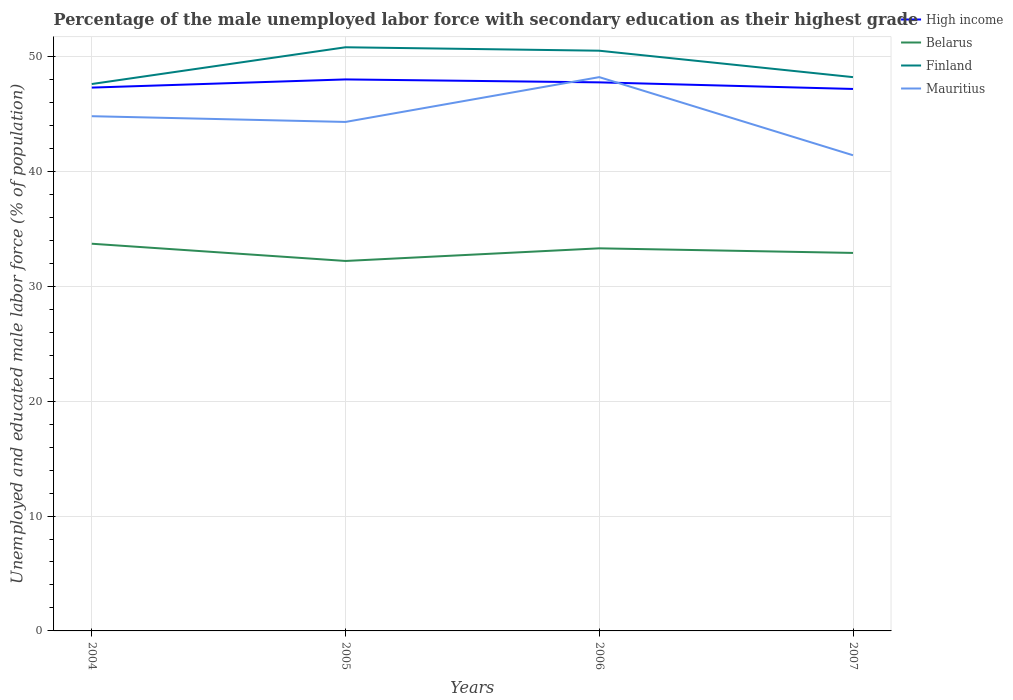Does the line corresponding to Finland intersect with the line corresponding to Belarus?
Your answer should be very brief. No. Across all years, what is the maximum percentage of the unemployed male labor force with secondary education in Finland?
Offer a very short reply. 47.6. In which year was the percentage of the unemployed male labor force with secondary education in Finland maximum?
Offer a terse response. 2004. What is the total percentage of the unemployed male labor force with secondary education in Belarus in the graph?
Your response must be concise. -1.1. What is the difference between the highest and the second highest percentage of the unemployed male labor force with secondary education in High income?
Your answer should be very brief. 0.83. What is the difference between the highest and the lowest percentage of the unemployed male labor force with secondary education in Mauritius?
Offer a very short reply. 2. How many years are there in the graph?
Make the answer very short. 4. What is the difference between two consecutive major ticks on the Y-axis?
Offer a very short reply. 10. Does the graph contain grids?
Offer a very short reply. Yes. How are the legend labels stacked?
Offer a very short reply. Vertical. What is the title of the graph?
Provide a succinct answer. Percentage of the male unemployed labor force with secondary education as their highest grade. What is the label or title of the Y-axis?
Your answer should be very brief. Unemployed and educated male labor force (% of population). What is the Unemployed and educated male labor force (% of population) of High income in 2004?
Offer a terse response. 47.29. What is the Unemployed and educated male labor force (% of population) in Belarus in 2004?
Provide a succinct answer. 33.7. What is the Unemployed and educated male labor force (% of population) of Finland in 2004?
Give a very brief answer. 47.6. What is the Unemployed and educated male labor force (% of population) of Mauritius in 2004?
Your answer should be very brief. 44.8. What is the Unemployed and educated male labor force (% of population) in High income in 2005?
Your response must be concise. 48. What is the Unemployed and educated male labor force (% of population) in Belarus in 2005?
Provide a succinct answer. 32.2. What is the Unemployed and educated male labor force (% of population) of Finland in 2005?
Keep it short and to the point. 50.8. What is the Unemployed and educated male labor force (% of population) in Mauritius in 2005?
Keep it short and to the point. 44.3. What is the Unemployed and educated male labor force (% of population) of High income in 2006?
Keep it short and to the point. 47.74. What is the Unemployed and educated male labor force (% of population) in Belarus in 2006?
Your answer should be very brief. 33.3. What is the Unemployed and educated male labor force (% of population) in Finland in 2006?
Your response must be concise. 50.5. What is the Unemployed and educated male labor force (% of population) in Mauritius in 2006?
Offer a very short reply. 48.2. What is the Unemployed and educated male labor force (% of population) in High income in 2007?
Offer a terse response. 47.17. What is the Unemployed and educated male labor force (% of population) in Belarus in 2007?
Your answer should be compact. 32.9. What is the Unemployed and educated male labor force (% of population) of Finland in 2007?
Offer a terse response. 48.2. What is the Unemployed and educated male labor force (% of population) in Mauritius in 2007?
Provide a short and direct response. 41.4. Across all years, what is the maximum Unemployed and educated male labor force (% of population) of High income?
Your answer should be compact. 48. Across all years, what is the maximum Unemployed and educated male labor force (% of population) of Belarus?
Give a very brief answer. 33.7. Across all years, what is the maximum Unemployed and educated male labor force (% of population) in Finland?
Make the answer very short. 50.8. Across all years, what is the maximum Unemployed and educated male labor force (% of population) of Mauritius?
Your answer should be compact. 48.2. Across all years, what is the minimum Unemployed and educated male labor force (% of population) of High income?
Provide a succinct answer. 47.17. Across all years, what is the minimum Unemployed and educated male labor force (% of population) of Belarus?
Offer a terse response. 32.2. Across all years, what is the minimum Unemployed and educated male labor force (% of population) of Finland?
Ensure brevity in your answer.  47.6. Across all years, what is the minimum Unemployed and educated male labor force (% of population) in Mauritius?
Provide a succinct answer. 41.4. What is the total Unemployed and educated male labor force (% of population) in High income in the graph?
Your answer should be very brief. 190.21. What is the total Unemployed and educated male labor force (% of population) in Belarus in the graph?
Provide a succinct answer. 132.1. What is the total Unemployed and educated male labor force (% of population) of Finland in the graph?
Offer a terse response. 197.1. What is the total Unemployed and educated male labor force (% of population) in Mauritius in the graph?
Ensure brevity in your answer.  178.7. What is the difference between the Unemployed and educated male labor force (% of population) in High income in 2004 and that in 2005?
Your answer should be very brief. -0.71. What is the difference between the Unemployed and educated male labor force (% of population) of Finland in 2004 and that in 2005?
Provide a succinct answer. -3.2. What is the difference between the Unemployed and educated male labor force (% of population) of High income in 2004 and that in 2006?
Provide a succinct answer. -0.46. What is the difference between the Unemployed and educated male labor force (% of population) of High income in 2004 and that in 2007?
Your response must be concise. 0.12. What is the difference between the Unemployed and educated male labor force (% of population) of Finland in 2004 and that in 2007?
Give a very brief answer. -0.6. What is the difference between the Unemployed and educated male labor force (% of population) of Mauritius in 2004 and that in 2007?
Your response must be concise. 3.4. What is the difference between the Unemployed and educated male labor force (% of population) of High income in 2005 and that in 2006?
Provide a succinct answer. 0.26. What is the difference between the Unemployed and educated male labor force (% of population) in Finland in 2005 and that in 2006?
Your answer should be very brief. 0.3. What is the difference between the Unemployed and educated male labor force (% of population) in Mauritius in 2005 and that in 2006?
Your response must be concise. -3.9. What is the difference between the Unemployed and educated male labor force (% of population) of High income in 2005 and that in 2007?
Provide a short and direct response. 0.83. What is the difference between the Unemployed and educated male labor force (% of population) of Belarus in 2005 and that in 2007?
Keep it short and to the point. -0.7. What is the difference between the Unemployed and educated male labor force (% of population) of Finland in 2005 and that in 2007?
Make the answer very short. 2.6. What is the difference between the Unemployed and educated male labor force (% of population) of High income in 2006 and that in 2007?
Keep it short and to the point. 0.57. What is the difference between the Unemployed and educated male labor force (% of population) of High income in 2004 and the Unemployed and educated male labor force (% of population) of Belarus in 2005?
Provide a short and direct response. 15.09. What is the difference between the Unemployed and educated male labor force (% of population) in High income in 2004 and the Unemployed and educated male labor force (% of population) in Finland in 2005?
Your answer should be very brief. -3.51. What is the difference between the Unemployed and educated male labor force (% of population) of High income in 2004 and the Unemployed and educated male labor force (% of population) of Mauritius in 2005?
Your response must be concise. 2.99. What is the difference between the Unemployed and educated male labor force (% of population) of Belarus in 2004 and the Unemployed and educated male labor force (% of population) of Finland in 2005?
Your response must be concise. -17.1. What is the difference between the Unemployed and educated male labor force (% of population) in Belarus in 2004 and the Unemployed and educated male labor force (% of population) in Mauritius in 2005?
Your answer should be very brief. -10.6. What is the difference between the Unemployed and educated male labor force (% of population) in Finland in 2004 and the Unemployed and educated male labor force (% of population) in Mauritius in 2005?
Your answer should be very brief. 3.3. What is the difference between the Unemployed and educated male labor force (% of population) in High income in 2004 and the Unemployed and educated male labor force (% of population) in Belarus in 2006?
Offer a very short reply. 13.99. What is the difference between the Unemployed and educated male labor force (% of population) of High income in 2004 and the Unemployed and educated male labor force (% of population) of Finland in 2006?
Your response must be concise. -3.21. What is the difference between the Unemployed and educated male labor force (% of population) of High income in 2004 and the Unemployed and educated male labor force (% of population) of Mauritius in 2006?
Give a very brief answer. -0.91. What is the difference between the Unemployed and educated male labor force (% of population) in Belarus in 2004 and the Unemployed and educated male labor force (% of population) in Finland in 2006?
Offer a very short reply. -16.8. What is the difference between the Unemployed and educated male labor force (% of population) in Finland in 2004 and the Unemployed and educated male labor force (% of population) in Mauritius in 2006?
Ensure brevity in your answer.  -0.6. What is the difference between the Unemployed and educated male labor force (% of population) of High income in 2004 and the Unemployed and educated male labor force (% of population) of Belarus in 2007?
Your answer should be very brief. 14.39. What is the difference between the Unemployed and educated male labor force (% of population) in High income in 2004 and the Unemployed and educated male labor force (% of population) in Finland in 2007?
Offer a very short reply. -0.91. What is the difference between the Unemployed and educated male labor force (% of population) of High income in 2004 and the Unemployed and educated male labor force (% of population) of Mauritius in 2007?
Offer a very short reply. 5.89. What is the difference between the Unemployed and educated male labor force (% of population) of Belarus in 2004 and the Unemployed and educated male labor force (% of population) of Mauritius in 2007?
Your answer should be very brief. -7.7. What is the difference between the Unemployed and educated male labor force (% of population) of High income in 2005 and the Unemployed and educated male labor force (% of population) of Belarus in 2006?
Keep it short and to the point. 14.7. What is the difference between the Unemployed and educated male labor force (% of population) of High income in 2005 and the Unemployed and educated male labor force (% of population) of Finland in 2006?
Offer a very short reply. -2.5. What is the difference between the Unemployed and educated male labor force (% of population) in High income in 2005 and the Unemployed and educated male labor force (% of population) in Mauritius in 2006?
Your response must be concise. -0.2. What is the difference between the Unemployed and educated male labor force (% of population) of Belarus in 2005 and the Unemployed and educated male labor force (% of population) of Finland in 2006?
Keep it short and to the point. -18.3. What is the difference between the Unemployed and educated male labor force (% of population) in Belarus in 2005 and the Unemployed and educated male labor force (% of population) in Mauritius in 2006?
Give a very brief answer. -16. What is the difference between the Unemployed and educated male labor force (% of population) in Finland in 2005 and the Unemployed and educated male labor force (% of population) in Mauritius in 2006?
Your response must be concise. 2.6. What is the difference between the Unemployed and educated male labor force (% of population) in High income in 2005 and the Unemployed and educated male labor force (% of population) in Belarus in 2007?
Make the answer very short. 15.1. What is the difference between the Unemployed and educated male labor force (% of population) in High income in 2005 and the Unemployed and educated male labor force (% of population) in Finland in 2007?
Your answer should be compact. -0.2. What is the difference between the Unemployed and educated male labor force (% of population) in High income in 2005 and the Unemployed and educated male labor force (% of population) in Mauritius in 2007?
Give a very brief answer. 6.6. What is the difference between the Unemployed and educated male labor force (% of population) of Belarus in 2005 and the Unemployed and educated male labor force (% of population) of Mauritius in 2007?
Provide a succinct answer. -9.2. What is the difference between the Unemployed and educated male labor force (% of population) in High income in 2006 and the Unemployed and educated male labor force (% of population) in Belarus in 2007?
Offer a terse response. 14.84. What is the difference between the Unemployed and educated male labor force (% of population) in High income in 2006 and the Unemployed and educated male labor force (% of population) in Finland in 2007?
Keep it short and to the point. -0.46. What is the difference between the Unemployed and educated male labor force (% of population) in High income in 2006 and the Unemployed and educated male labor force (% of population) in Mauritius in 2007?
Your answer should be very brief. 6.34. What is the difference between the Unemployed and educated male labor force (% of population) in Belarus in 2006 and the Unemployed and educated male labor force (% of population) in Finland in 2007?
Provide a short and direct response. -14.9. What is the average Unemployed and educated male labor force (% of population) in High income per year?
Give a very brief answer. 47.55. What is the average Unemployed and educated male labor force (% of population) of Belarus per year?
Offer a terse response. 33.02. What is the average Unemployed and educated male labor force (% of population) of Finland per year?
Your answer should be very brief. 49.27. What is the average Unemployed and educated male labor force (% of population) in Mauritius per year?
Your answer should be compact. 44.67. In the year 2004, what is the difference between the Unemployed and educated male labor force (% of population) in High income and Unemployed and educated male labor force (% of population) in Belarus?
Offer a terse response. 13.59. In the year 2004, what is the difference between the Unemployed and educated male labor force (% of population) in High income and Unemployed and educated male labor force (% of population) in Finland?
Give a very brief answer. -0.31. In the year 2004, what is the difference between the Unemployed and educated male labor force (% of population) in High income and Unemployed and educated male labor force (% of population) in Mauritius?
Ensure brevity in your answer.  2.49. In the year 2004, what is the difference between the Unemployed and educated male labor force (% of population) in Belarus and Unemployed and educated male labor force (% of population) in Finland?
Provide a succinct answer. -13.9. In the year 2004, what is the difference between the Unemployed and educated male labor force (% of population) of Finland and Unemployed and educated male labor force (% of population) of Mauritius?
Make the answer very short. 2.8. In the year 2005, what is the difference between the Unemployed and educated male labor force (% of population) in High income and Unemployed and educated male labor force (% of population) in Belarus?
Offer a very short reply. 15.8. In the year 2005, what is the difference between the Unemployed and educated male labor force (% of population) in High income and Unemployed and educated male labor force (% of population) in Finland?
Give a very brief answer. -2.8. In the year 2005, what is the difference between the Unemployed and educated male labor force (% of population) in High income and Unemployed and educated male labor force (% of population) in Mauritius?
Give a very brief answer. 3.7. In the year 2005, what is the difference between the Unemployed and educated male labor force (% of population) of Belarus and Unemployed and educated male labor force (% of population) of Finland?
Your answer should be compact. -18.6. In the year 2005, what is the difference between the Unemployed and educated male labor force (% of population) in Belarus and Unemployed and educated male labor force (% of population) in Mauritius?
Provide a succinct answer. -12.1. In the year 2005, what is the difference between the Unemployed and educated male labor force (% of population) in Finland and Unemployed and educated male labor force (% of population) in Mauritius?
Provide a short and direct response. 6.5. In the year 2006, what is the difference between the Unemployed and educated male labor force (% of population) in High income and Unemployed and educated male labor force (% of population) in Belarus?
Offer a very short reply. 14.44. In the year 2006, what is the difference between the Unemployed and educated male labor force (% of population) in High income and Unemployed and educated male labor force (% of population) in Finland?
Provide a succinct answer. -2.76. In the year 2006, what is the difference between the Unemployed and educated male labor force (% of population) of High income and Unemployed and educated male labor force (% of population) of Mauritius?
Make the answer very short. -0.46. In the year 2006, what is the difference between the Unemployed and educated male labor force (% of population) of Belarus and Unemployed and educated male labor force (% of population) of Finland?
Your answer should be very brief. -17.2. In the year 2006, what is the difference between the Unemployed and educated male labor force (% of population) of Belarus and Unemployed and educated male labor force (% of population) of Mauritius?
Keep it short and to the point. -14.9. In the year 2006, what is the difference between the Unemployed and educated male labor force (% of population) of Finland and Unemployed and educated male labor force (% of population) of Mauritius?
Your response must be concise. 2.3. In the year 2007, what is the difference between the Unemployed and educated male labor force (% of population) of High income and Unemployed and educated male labor force (% of population) of Belarus?
Provide a succinct answer. 14.27. In the year 2007, what is the difference between the Unemployed and educated male labor force (% of population) of High income and Unemployed and educated male labor force (% of population) of Finland?
Your answer should be compact. -1.03. In the year 2007, what is the difference between the Unemployed and educated male labor force (% of population) of High income and Unemployed and educated male labor force (% of population) of Mauritius?
Ensure brevity in your answer.  5.77. In the year 2007, what is the difference between the Unemployed and educated male labor force (% of population) of Belarus and Unemployed and educated male labor force (% of population) of Finland?
Your answer should be compact. -15.3. What is the ratio of the Unemployed and educated male labor force (% of population) in High income in 2004 to that in 2005?
Provide a succinct answer. 0.99. What is the ratio of the Unemployed and educated male labor force (% of population) of Belarus in 2004 to that in 2005?
Offer a terse response. 1.05. What is the ratio of the Unemployed and educated male labor force (% of population) in Finland in 2004 to that in 2005?
Provide a succinct answer. 0.94. What is the ratio of the Unemployed and educated male labor force (% of population) in Mauritius in 2004 to that in 2005?
Make the answer very short. 1.01. What is the ratio of the Unemployed and educated male labor force (% of population) in High income in 2004 to that in 2006?
Give a very brief answer. 0.99. What is the ratio of the Unemployed and educated male labor force (% of population) of Belarus in 2004 to that in 2006?
Ensure brevity in your answer.  1.01. What is the ratio of the Unemployed and educated male labor force (% of population) of Finland in 2004 to that in 2006?
Your answer should be compact. 0.94. What is the ratio of the Unemployed and educated male labor force (% of population) in Mauritius in 2004 to that in 2006?
Offer a very short reply. 0.93. What is the ratio of the Unemployed and educated male labor force (% of population) in High income in 2004 to that in 2007?
Your answer should be compact. 1. What is the ratio of the Unemployed and educated male labor force (% of population) in Belarus in 2004 to that in 2007?
Your response must be concise. 1.02. What is the ratio of the Unemployed and educated male labor force (% of population) of Finland in 2004 to that in 2007?
Ensure brevity in your answer.  0.99. What is the ratio of the Unemployed and educated male labor force (% of population) in Mauritius in 2004 to that in 2007?
Provide a short and direct response. 1.08. What is the ratio of the Unemployed and educated male labor force (% of population) of High income in 2005 to that in 2006?
Your answer should be compact. 1.01. What is the ratio of the Unemployed and educated male labor force (% of population) of Belarus in 2005 to that in 2006?
Offer a very short reply. 0.97. What is the ratio of the Unemployed and educated male labor force (% of population) in Finland in 2005 to that in 2006?
Make the answer very short. 1.01. What is the ratio of the Unemployed and educated male labor force (% of population) of Mauritius in 2005 to that in 2006?
Provide a succinct answer. 0.92. What is the ratio of the Unemployed and educated male labor force (% of population) of High income in 2005 to that in 2007?
Your answer should be compact. 1.02. What is the ratio of the Unemployed and educated male labor force (% of population) of Belarus in 2005 to that in 2007?
Provide a succinct answer. 0.98. What is the ratio of the Unemployed and educated male labor force (% of population) in Finland in 2005 to that in 2007?
Offer a terse response. 1.05. What is the ratio of the Unemployed and educated male labor force (% of population) in Mauritius in 2005 to that in 2007?
Keep it short and to the point. 1.07. What is the ratio of the Unemployed and educated male labor force (% of population) of High income in 2006 to that in 2007?
Provide a succinct answer. 1.01. What is the ratio of the Unemployed and educated male labor force (% of population) in Belarus in 2006 to that in 2007?
Offer a terse response. 1.01. What is the ratio of the Unemployed and educated male labor force (% of population) of Finland in 2006 to that in 2007?
Your answer should be compact. 1.05. What is the ratio of the Unemployed and educated male labor force (% of population) in Mauritius in 2006 to that in 2007?
Your response must be concise. 1.16. What is the difference between the highest and the second highest Unemployed and educated male labor force (% of population) of High income?
Provide a succinct answer. 0.26. What is the difference between the highest and the second highest Unemployed and educated male labor force (% of population) in Finland?
Keep it short and to the point. 0.3. What is the difference between the highest and the lowest Unemployed and educated male labor force (% of population) in High income?
Offer a very short reply. 0.83. 